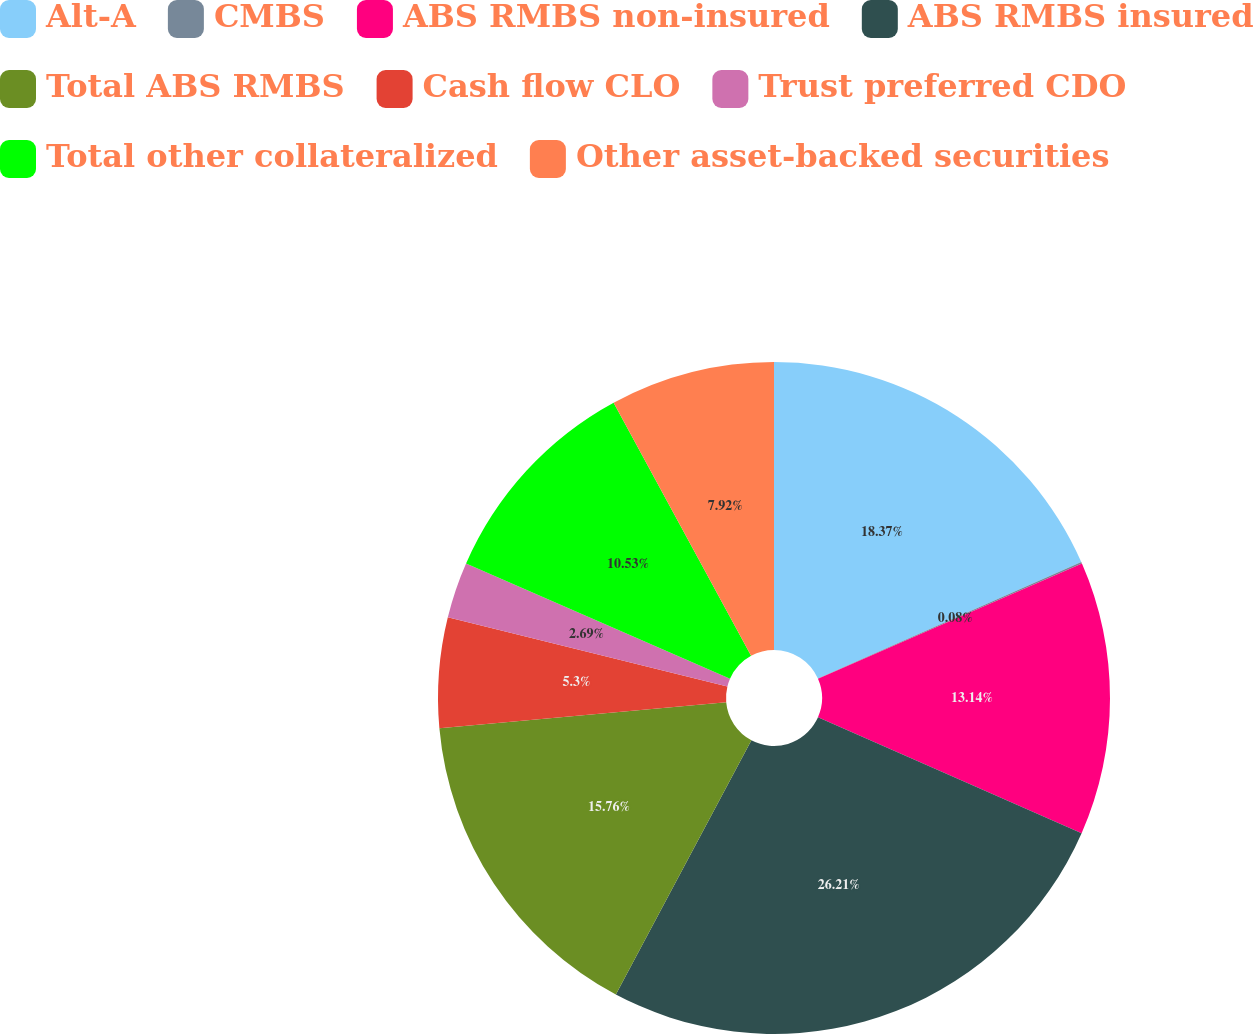Convert chart. <chart><loc_0><loc_0><loc_500><loc_500><pie_chart><fcel>Alt-A<fcel>CMBS<fcel>ABS RMBS non-insured<fcel>ABS RMBS insured<fcel>Total ABS RMBS<fcel>Cash flow CLO<fcel>Trust preferred CDO<fcel>Total other collateralized<fcel>Other asset-backed securities<nl><fcel>18.37%<fcel>0.08%<fcel>13.14%<fcel>26.21%<fcel>15.76%<fcel>5.3%<fcel>2.69%<fcel>10.53%<fcel>7.92%<nl></chart> 